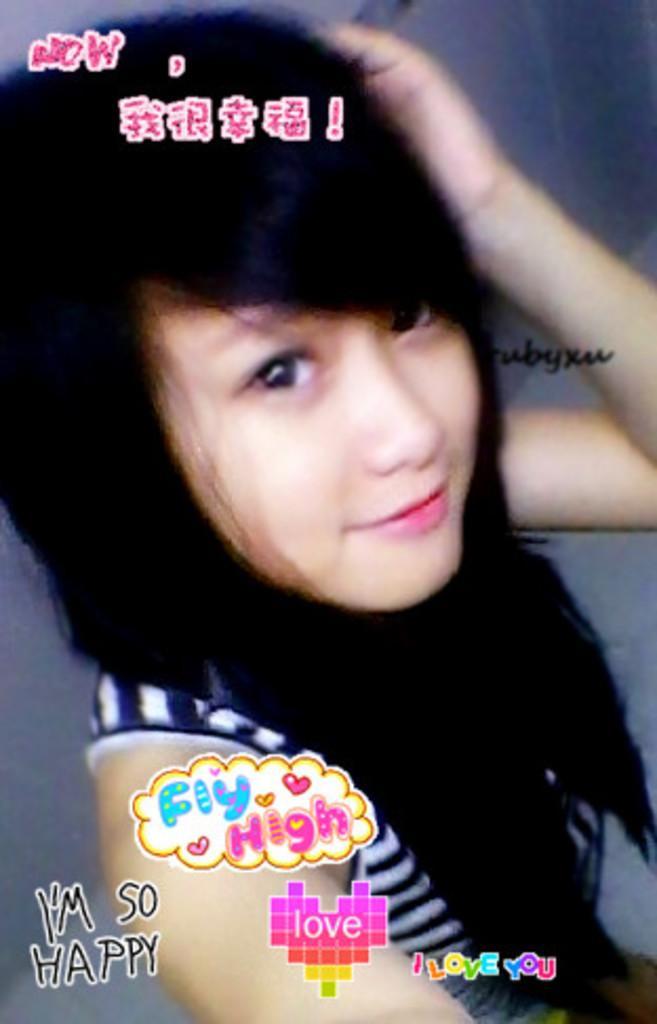How would you summarize this image in a sentence or two? In this image, we can see a woman, we can also see some text written on the image. 